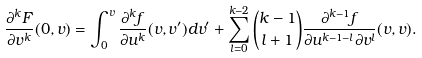<formula> <loc_0><loc_0><loc_500><loc_500>\frac { \partial ^ { k } F } { \partial v ^ { k } } ( 0 , v ) = \int _ { 0 } ^ { v } \frac { \partial ^ { k } f } { \partial u ^ { k } } ( v , v ^ { \prime } ) d v ^ { \prime } + \sum _ { l = 0 } ^ { k - 2 } \binom { k - 1 } { l + 1 } \frac { \partial ^ { k - 1 } f } { \partial u ^ { k - 1 - l } \partial v ^ { l } } ( v , v ) .</formula> 